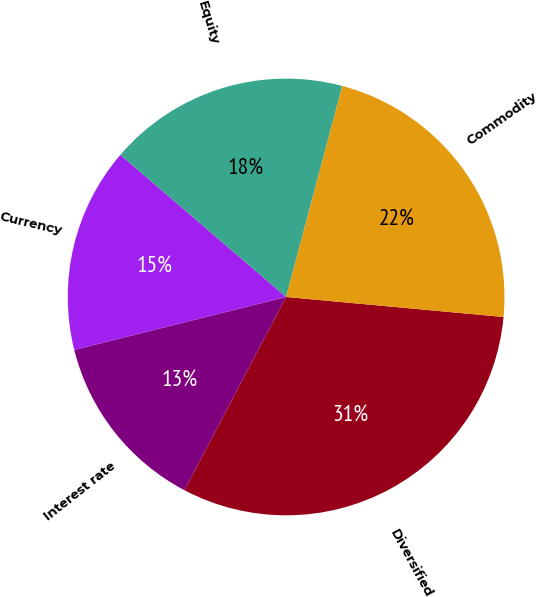Convert chart. <chart><loc_0><loc_0><loc_500><loc_500><pie_chart><fcel>Diversified<fcel>Interest rate<fcel>Currency<fcel>Equity<fcel>Commodity<nl><fcel>31.25%<fcel>13.39%<fcel>15.18%<fcel>17.86%<fcel>22.32%<nl></chart> 